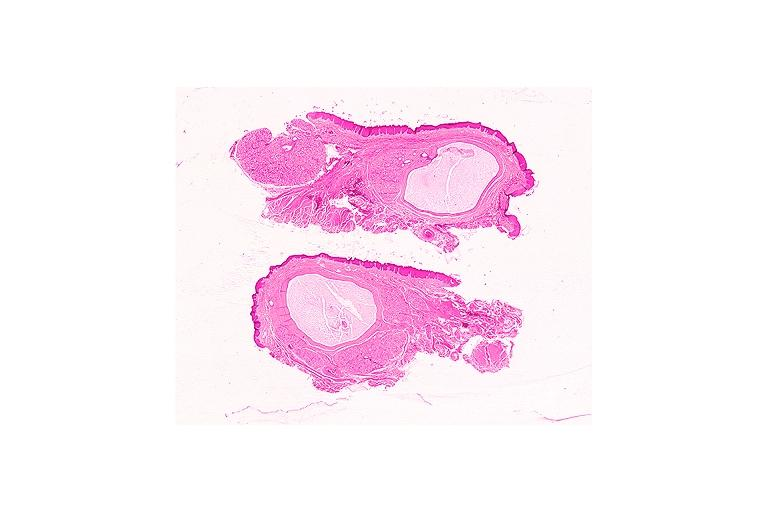does face show mucocele?
Answer the question using a single word or phrase. No 